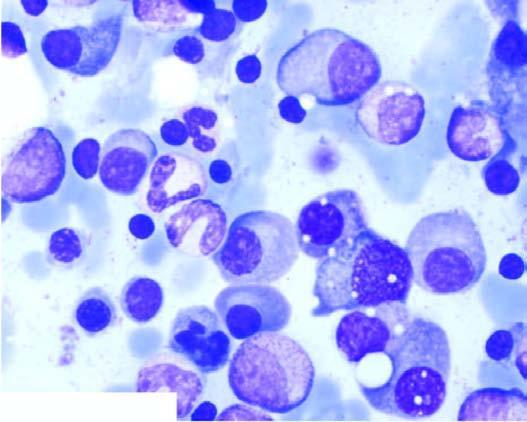does one marrow aspirate in myeloma show numerous plasma cells, many with abnormal features?
Answer the question using a single word or phrase. Yes 